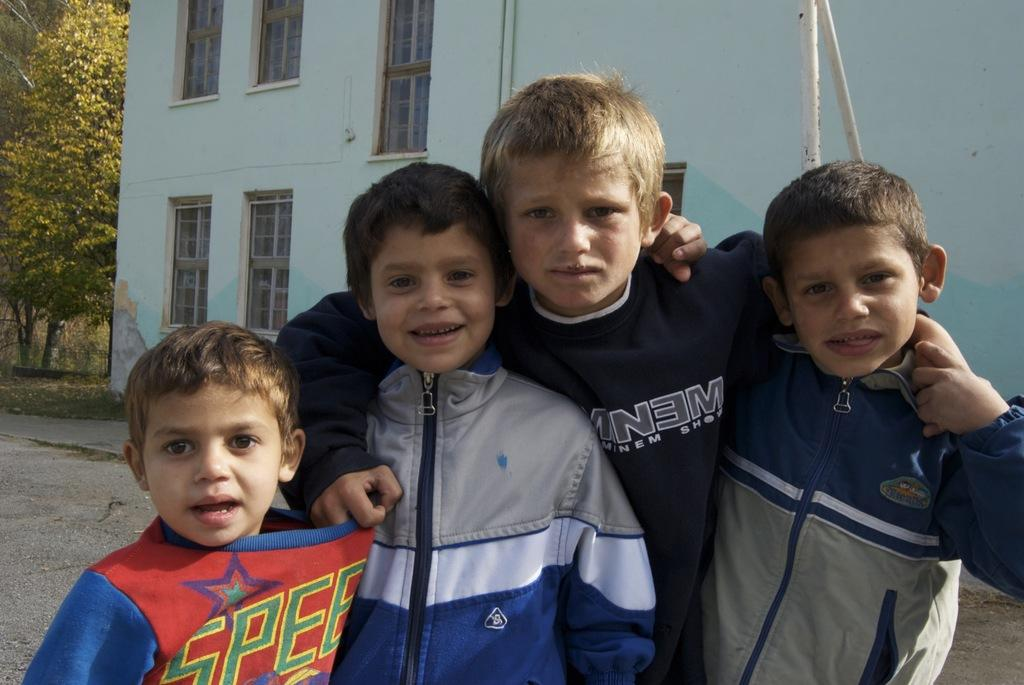<image>
Write a terse but informative summary of the picture. young boys in front of a blue building and one in a SPEE shirt 